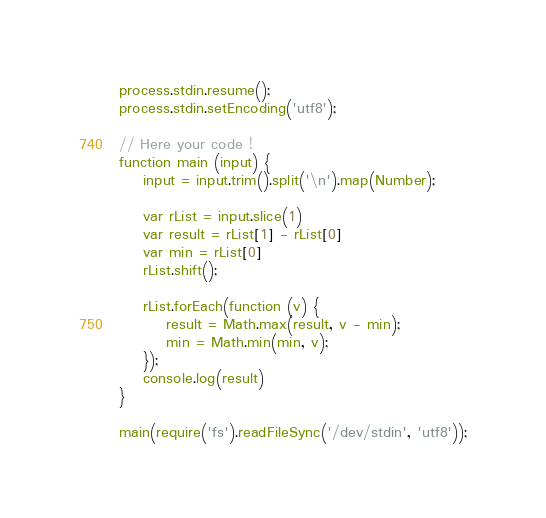Convert code to text. <code><loc_0><loc_0><loc_500><loc_500><_JavaScript_>process.stdin.resume();
process.stdin.setEncoding('utf8');

// Here your code !
function main (input) {
    input = input.trim().split('\n').map(Number);
    
    var rList = input.slice(1)
    var result = rList[1] - rList[0]
    var min = rList[0]
    rList.shift();
    
    rList.forEach(function (v) {
        result = Math.max(result, v - min);
        min = Math.min(min, v);
    });
    console.log(result)
}

main(require('fs').readFileSync('/dev/stdin', 'utf8'));</code> 